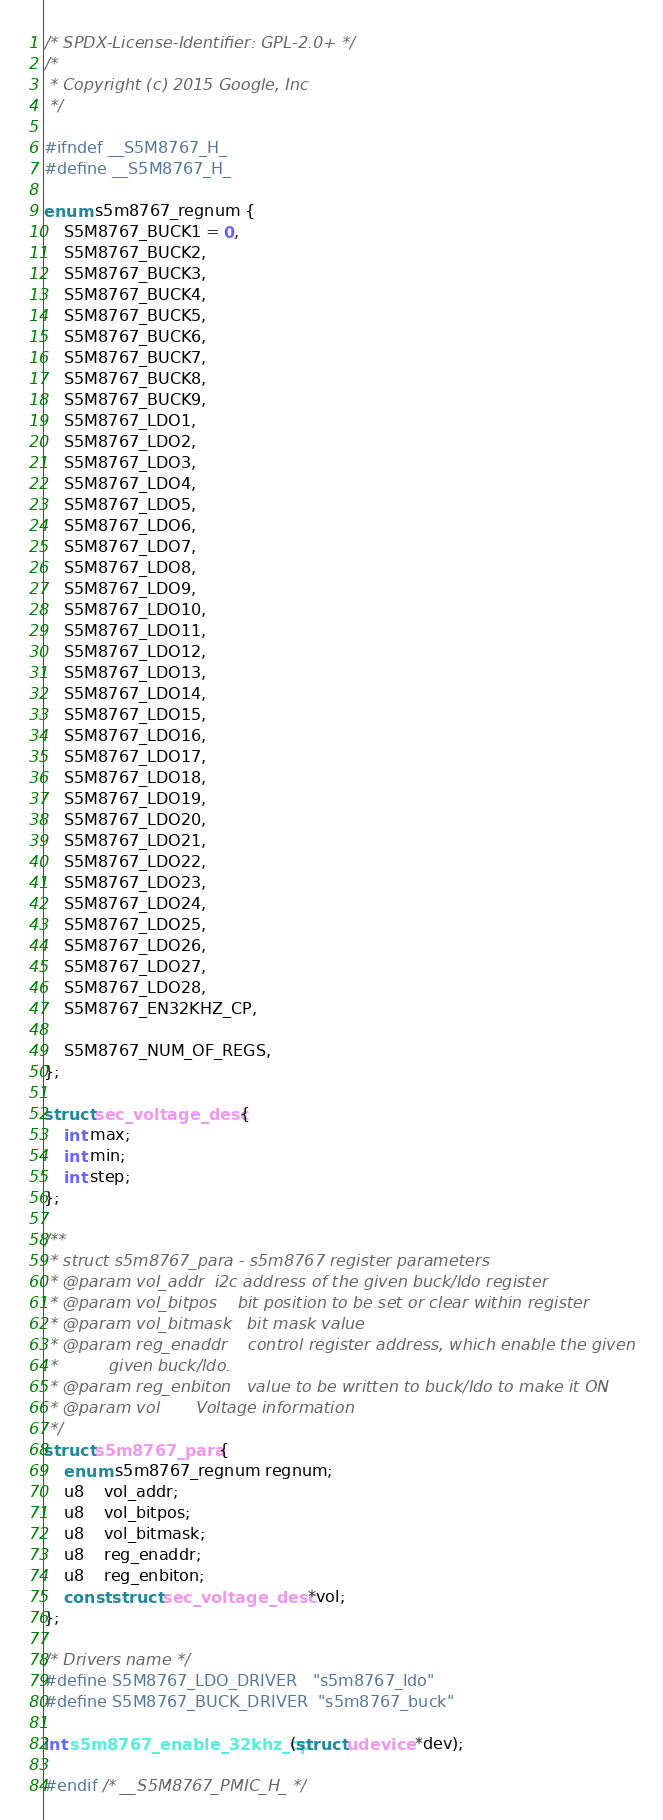Convert code to text. <code><loc_0><loc_0><loc_500><loc_500><_C_>/* SPDX-License-Identifier: GPL-2.0+ */
/*
 * Copyright (c) 2015 Google, Inc
 */

#ifndef __S5M8767_H_
#define __S5M8767_H_

enum s5m8767_regnum {
	S5M8767_BUCK1 = 0,
	S5M8767_BUCK2,
	S5M8767_BUCK3,
	S5M8767_BUCK4,
	S5M8767_BUCK5,
	S5M8767_BUCK6,
	S5M8767_BUCK7,
	S5M8767_BUCK8,
	S5M8767_BUCK9,
	S5M8767_LDO1,
	S5M8767_LDO2,
	S5M8767_LDO3,
	S5M8767_LDO4,
	S5M8767_LDO5,
	S5M8767_LDO6,
	S5M8767_LDO7,
	S5M8767_LDO8,
	S5M8767_LDO9,
	S5M8767_LDO10,
	S5M8767_LDO11,
	S5M8767_LDO12,
	S5M8767_LDO13,
	S5M8767_LDO14,
	S5M8767_LDO15,
	S5M8767_LDO16,
	S5M8767_LDO17,
	S5M8767_LDO18,
	S5M8767_LDO19,
	S5M8767_LDO20,
	S5M8767_LDO21,
	S5M8767_LDO22,
	S5M8767_LDO23,
	S5M8767_LDO24,
	S5M8767_LDO25,
	S5M8767_LDO26,
	S5M8767_LDO27,
	S5M8767_LDO28,
	S5M8767_EN32KHZ_CP,

	S5M8767_NUM_OF_REGS,
};

struct sec_voltage_desc {
	int max;
	int min;
	int step;
};

/**
 * struct s5m8767_para - s5m8767 register parameters
 * @param vol_addr	i2c address of the given buck/ldo register
 * @param vol_bitpos	bit position to be set or clear within register
 * @param vol_bitmask	bit mask value
 * @param reg_enaddr	control register address, which enable the given
 *			given buck/ldo.
 * @param reg_enbiton	value to be written to buck/ldo to make it ON
 * @param vol		Voltage information
 */
struct s5m8767_para {
	enum s5m8767_regnum regnum;
	u8	vol_addr;
	u8	vol_bitpos;
	u8	vol_bitmask;
	u8	reg_enaddr;
	u8	reg_enbiton;
	const struct sec_voltage_desc *vol;
};

/* Drivers name */
#define S5M8767_LDO_DRIVER	"s5m8767_ldo"
#define S5M8767_BUCK_DRIVER	"s5m8767_buck"

int s5m8767_enable_32khz_cp(struct udevice *dev);

#endif /* __S5M8767_PMIC_H_ */
</code> 